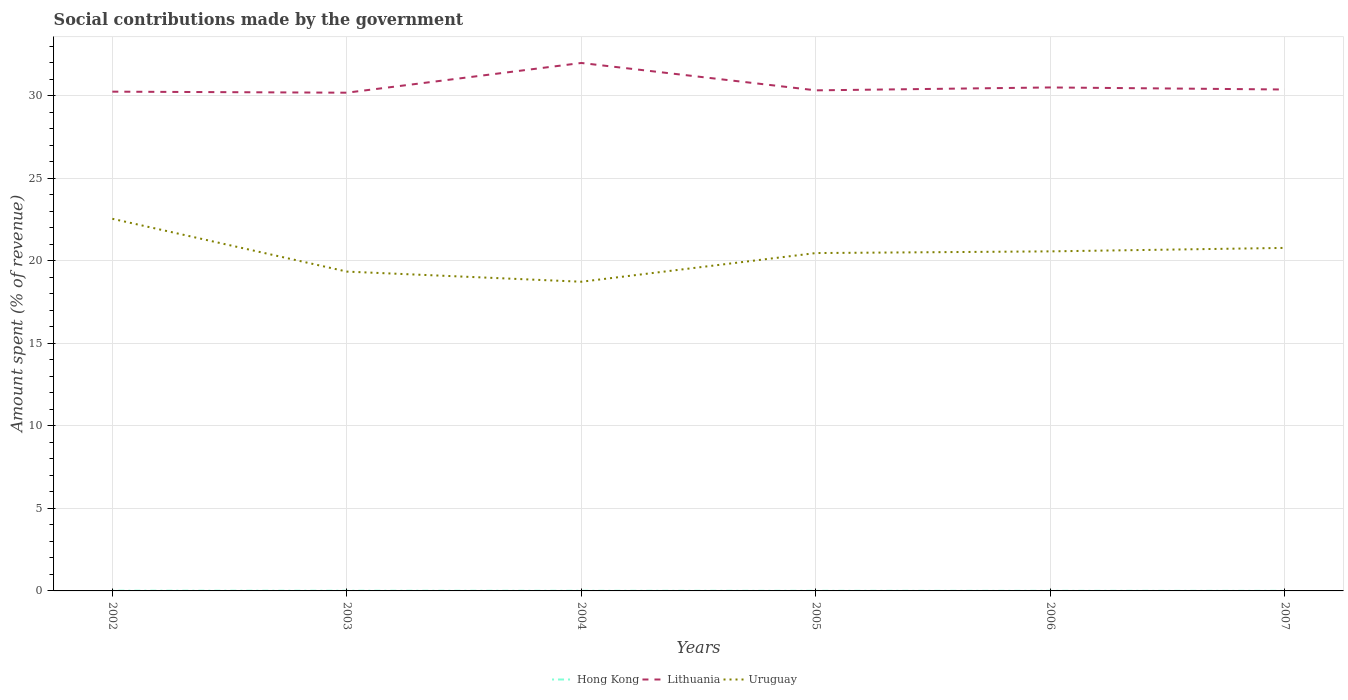Is the number of lines equal to the number of legend labels?
Give a very brief answer. Yes. Across all years, what is the maximum amount spent (in %) on social contributions in Uruguay?
Make the answer very short. 18.74. In which year was the amount spent (in %) on social contributions in Uruguay maximum?
Provide a succinct answer. 2004. What is the total amount spent (in %) on social contributions in Lithuania in the graph?
Your answer should be compact. -0.14. What is the difference between the highest and the second highest amount spent (in %) on social contributions in Hong Kong?
Your answer should be compact. 0.01. How many years are there in the graph?
Provide a succinct answer. 6. What is the difference between two consecutive major ticks on the Y-axis?
Provide a short and direct response. 5. Are the values on the major ticks of Y-axis written in scientific E-notation?
Keep it short and to the point. No. Does the graph contain any zero values?
Ensure brevity in your answer.  No. Does the graph contain grids?
Offer a very short reply. Yes. Where does the legend appear in the graph?
Offer a very short reply. Bottom center. What is the title of the graph?
Your answer should be very brief. Social contributions made by the government. Does "Mongolia" appear as one of the legend labels in the graph?
Your answer should be very brief. No. What is the label or title of the Y-axis?
Your answer should be very brief. Amount spent (% of revenue). What is the Amount spent (% of revenue) of Hong Kong in 2002?
Provide a short and direct response. 0.01. What is the Amount spent (% of revenue) of Lithuania in 2002?
Ensure brevity in your answer.  30.25. What is the Amount spent (% of revenue) of Uruguay in 2002?
Offer a terse response. 22.55. What is the Amount spent (% of revenue) in Hong Kong in 2003?
Ensure brevity in your answer.  0.01. What is the Amount spent (% of revenue) of Lithuania in 2003?
Your answer should be compact. 30.19. What is the Amount spent (% of revenue) of Uruguay in 2003?
Your answer should be compact. 19.35. What is the Amount spent (% of revenue) of Hong Kong in 2004?
Offer a terse response. 0.01. What is the Amount spent (% of revenue) of Lithuania in 2004?
Make the answer very short. 31.99. What is the Amount spent (% of revenue) in Uruguay in 2004?
Your answer should be compact. 18.74. What is the Amount spent (% of revenue) of Hong Kong in 2005?
Offer a terse response. 0.01. What is the Amount spent (% of revenue) of Lithuania in 2005?
Make the answer very short. 30.33. What is the Amount spent (% of revenue) in Uruguay in 2005?
Offer a very short reply. 20.47. What is the Amount spent (% of revenue) in Hong Kong in 2006?
Offer a terse response. 0.01. What is the Amount spent (% of revenue) of Lithuania in 2006?
Offer a terse response. 30.51. What is the Amount spent (% of revenue) of Uruguay in 2006?
Keep it short and to the point. 20.58. What is the Amount spent (% of revenue) in Hong Kong in 2007?
Offer a very short reply. 0. What is the Amount spent (% of revenue) in Lithuania in 2007?
Provide a succinct answer. 30.38. What is the Amount spent (% of revenue) in Uruguay in 2007?
Your answer should be very brief. 20.79. Across all years, what is the maximum Amount spent (% of revenue) of Hong Kong?
Offer a very short reply. 0.01. Across all years, what is the maximum Amount spent (% of revenue) in Lithuania?
Your response must be concise. 31.99. Across all years, what is the maximum Amount spent (% of revenue) in Uruguay?
Make the answer very short. 22.55. Across all years, what is the minimum Amount spent (% of revenue) in Hong Kong?
Offer a terse response. 0. Across all years, what is the minimum Amount spent (% of revenue) in Lithuania?
Make the answer very short. 30.19. Across all years, what is the minimum Amount spent (% of revenue) in Uruguay?
Keep it short and to the point. 18.74. What is the total Amount spent (% of revenue) in Hong Kong in the graph?
Make the answer very short. 0.05. What is the total Amount spent (% of revenue) of Lithuania in the graph?
Your response must be concise. 183.66. What is the total Amount spent (% of revenue) of Uruguay in the graph?
Your response must be concise. 122.47. What is the difference between the Amount spent (% of revenue) in Hong Kong in 2002 and that in 2003?
Give a very brief answer. 0. What is the difference between the Amount spent (% of revenue) in Lithuania in 2002 and that in 2003?
Offer a terse response. 0.06. What is the difference between the Amount spent (% of revenue) of Uruguay in 2002 and that in 2003?
Your answer should be compact. 3.2. What is the difference between the Amount spent (% of revenue) in Hong Kong in 2002 and that in 2004?
Keep it short and to the point. 0.01. What is the difference between the Amount spent (% of revenue) of Lithuania in 2002 and that in 2004?
Your answer should be compact. -1.74. What is the difference between the Amount spent (% of revenue) in Uruguay in 2002 and that in 2004?
Give a very brief answer. 3.81. What is the difference between the Amount spent (% of revenue) of Hong Kong in 2002 and that in 2005?
Your answer should be very brief. 0.01. What is the difference between the Amount spent (% of revenue) in Lithuania in 2002 and that in 2005?
Make the answer very short. -0.08. What is the difference between the Amount spent (% of revenue) in Uruguay in 2002 and that in 2005?
Give a very brief answer. 2.08. What is the difference between the Amount spent (% of revenue) in Hong Kong in 2002 and that in 2006?
Make the answer very short. 0.01. What is the difference between the Amount spent (% of revenue) in Lithuania in 2002 and that in 2006?
Offer a terse response. -0.25. What is the difference between the Amount spent (% of revenue) in Uruguay in 2002 and that in 2006?
Your response must be concise. 1.97. What is the difference between the Amount spent (% of revenue) of Hong Kong in 2002 and that in 2007?
Offer a very short reply. 0.01. What is the difference between the Amount spent (% of revenue) in Lithuania in 2002 and that in 2007?
Offer a terse response. -0.13. What is the difference between the Amount spent (% of revenue) of Uruguay in 2002 and that in 2007?
Ensure brevity in your answer.  1.76. What is the difference between the Amount spent (% of revenue) of Hong Kong in 2003 and that in 2004?
Provide a succinct answer. 0. What is the difference between the Amount spent (% of revenue) of Lithuania in 2003 and that in 2004?
Make the answer very short. -1.8. What is the difference between the Amount spent (% of revenue) of Uruguay in 2003 and that in 2004?
Provide a succinct answer. 0.61. What is the difference between the Amount spent (% of revenue) of Hong Kong in 2003 and that in 2005?
Your answer should be compact. 0. What is the difference between the Amount spent (% of revenue) in Lithuania in 2003 and that in 2005?
Offer a terse response. -0.14. What is the difference between the Amount spent (% of revenue) of Uruguay in 2003 and that in 2005?
Ensure brevity in your answer.  -1.12. What is the difference between the Amount spent (% of revenue) in Hong Kong in 2003 and that in 2006?
Your response must be concise. 0.01. What is the difference between the Amount spent (% of revenue) in Lithuania in 2003 and that in 2006?
Offer a very short reply. -0.32. What is the difference between the Amount spent (% of revenue) in Uruguay in 2003 and that in 2006?
Ensure brevity in your answer.  -1.23. What is the difference between the Amount spent (% of revenue) of Hong Kong in 2003 and that in 2007?
Ensure brevity in your answer.  0.01. What is the difference between the Amount spent (% of revenue) in Lithuania in 2003 and that in 2007?
Provide a short and direct response. -0.19. What is the difference between the Amount spent (% of revenue) of Uruguay in 2003 and that in 2007?
Offer a very short reply. -1.44. What is the difference between the Amount spent (% of revenue) in Hong Kong in 2004 and that in 2005?
Provide a short and direct response. 0. What is the difference between the Amount spent (% of revenue) in Lithuania in 2004 and that in 2005?
Keep it short and to the point. 1.66. What is the difference between the Amount spent (% of revenue) in Uruguay in 2004 and that in 2005?
Provide a short and direct response. -1.74. What is the difference between the Amount spent (% of revenue) of Hong Kong in 2004 and that in 2006?
Give a very brief answer. 0. What is the difference between the Amount spent (% of revenue) of Lithuania in 2004 and that in 2006?
Offer a very short reply. 1.48. What is the difference between the Amount spent (% of revenue) in Uruguay in 2004 and that in 2006?
Offer a terse response. -1.84. What is the difference between the Amount spent (% of revenue) in Hong Kong in 2004 and that in 2007?
Provide a short and direct response. 0. What is the difference between the Amount spent (% of revenue) in Lithuania in 2004 and that in 2007?
Ensure brevity in your answer.  1.61. What is the difference between the Amount spent (% of revenue) of Uruguay in 2004 and that in 2007?
Your answer should be very brief. -2.05. What is the difference between the Amount spent (% of revenue) of Hong Kong in 2005 and that in 2006?
Provide a succinct answer. 0. What is the difference between the Amount spent (% of revenue) of Lithuania in 2005 and that in 2006?
Your answer should be compact. -0.18. What is the difference between the Amount spent (% of revenue) of Uruguay in 2005 and that in 2006?
Keep it short and to the point. -0.1. What is the difference between the Amount spent (% of revenue) in Hong Kong in 2005 and that in 2007?
Make the answer very short. 0. What is the difference between the Amount spent (% of revenue) of Lithuania in 2005 and that in 2007?
Your answer should be compact. -0.05. What is the difference between the Amount spent (% of revenue) of Uruguay in 2005 and that in 2007?
Give a very brief answer. -0.31. What is the difference between the Amount spent (% of revenue) in Hong Kong in 2006 and that in 2007?
Your answer should be compact. 0. What is the difference between the Amount spent (% of revenue) of Lithuania in 2006 and that in 2007?
Make the answer very short. 0.12. What is the difference between the Amount spent (% of revenue) of Uruguay in 2006 and that in 2007?
Provide a short and direct response. -0.21. What is the difference between the Amount spent (% of revenue) in Hong Kong in 2002 and the Amount spent (% of revenue) in Lithuania in 2003?
Your answer should be compact. -30.18. What is the difference between the Amount spent (% of revenue) in Hong Kong in 2002 and the Amount spent (% of revenue) in Uruguay in 2003?
Provide a short and direct response. -19.34. What is the difference between the Amount spent (% of revenue) in Lithuania in 2002 and the Amount spent (% of revenue) in Uruguay in 2003?
Your answer should be very brief. 10.9. What is the difference between the Amount spent (% of revenue) in Hong Kong in 2002 and the Amount spent (% of revenue) in Lithuania in 2004?
Ensure brevity in your answer.  -31.98. What is the difference between the Amount spent (% of revenue) in Hong Kong in 2002 and the Amount spent (% of revenue) in Uruguay in 2004?
Offer a terse response. -18.72. What is the difference between the Amount spent (% of revenue) in Lithuania in 2002 and the Amount spent (% of revenue) in Uruguay in 2004?
Offer a terse response. 11.52. What is the difference between the Amount spent (% of revenue) in Hong Kong in 2002 and the Amount spent (% of revenue) in Lithuania in 2005?
Your answer should be compact. -30.32. What is the difference between the Amount spent (% of revenue) of Hong Kong in 2002 and the Amount spent (% of revenue) of Uruguay in 2005?
Your response must be concise. -20.46. What is the difference between the Amount spent (% of revenue) of Lithuania in 2002 and the Amount spent (% of revenue) of Uruguay in 2005?
Provide a succinct answer. 9.78. What is the difference between the Amount spent (% of revenue) of Hong Kong in 2002 and the Amount spent (% of revenue) of Lithuania in 2006?
Provide a succinct answer. -30.49. What is the difference between the Amount spent (% of revenue) in Hong Kong in 2002 and the Amount spent (% of revenue) in Uruguay in 2006?
Make the answer very short. -20.56. What is the difference between the Amount spent (% of revenue) in Lithuania in 2002 and the Amount spent (% of revenue) in Uruguay in 2006?
Offer a very short reply. 9.68. What is the difference between the Amount spent (% of revenue) in Hong Kong in 2002 and the Amount spent (% of revenue) in Lithuania in 2007?
Ensure brevity in your answer.  -30.37. What is the difference between the Amount spent (% of revenue) of Hong Kong in 2002 and the Amount spent (% of revenue) of Uruguay in 2007?
Your response must be concise. -20.77. What is the difference between the Amount spent (% of revenue) in Lithuania in 2002 and the Amount spent (% of revenue) in Uruguay in 2007?
Offer a terse response. 9.47. What is the difference between the Amount spent (% of revenue) in Hong Kong in 2003 and the Amount spent (% of revenue) in Lithuania in 2004?
Offer a terse response. -31.98. What is the difference between the Amount spent (% of revenue) in Hong Kong in 2003 and the Amount spent (% of revenue) in Uruguay in 2004?
Offer a terse response. -18.72. What is the difference between the Amount spent (% of revenue) in Lithuania in 2003 and the Amount spent (% of revenue) in Uruguay in 2004?
Your answer should be very brief. 11.45. What is the difference between the Amount spent (% of revenue) in Hong Kong in 2003 and the Amount spent (% of revenue) in Lithuania in 2005?
Keep it short and to the point. -30.32. What is the difference between the Amount spent (% of revenue) in Hong Kong in 2003 and the Amount spent (% of revenue) in Uruguay in 2005?
Give a very brief answer. -20.46. What is the difference between the Amount spent (% of revenue) of Lithuania in 2003 and the Amount spent (% of revenue) of Uruguay in 2005?
Make the answer very short. 9.72. What is the difference between the Amount spent (% of revenue) of Hong Kong in 2003 and the Amount spent (% of revenue) of Lithuania in 2006?
Provide a short and direct response. -30.5. What is the difference between the Amount spent (% of revenue) of Hong Kong in 2003 and the Amount spent (% of revenue) of Uruguay in 2006?
Keep it short and to the point. -20.56. What is the difference between the Amount spent (% of revenue) of Lithuania in 2003 and the Amount spent (% of revenue) of Uruguay in 2006?
Make the answer very short. 9.62. What is the difference between the Amount spent (% of revenue) in Hong Kong in 2003 and the Amount spent (% of revenue) in Lithuania in 2007?
Ensure brevity in your answer.  -30.37. What is the difference between the Amount spent (% of revenue) of Hong Kong in 2003 and the Amount spent (% of revenue) of Uruguay in 2007?
Make the answer very short. -20.77. What is the difference between the Amount spent (% of revenue) of Lithuania in 2003 and the Amount spent (% of revenue) of Uruguay in 2007?
Make the answer very short. 9.41. What is the difference between the Amount spent (% of revenue) of Hong Kong in 2004 and the Amount spent (% of revenue) of Lithuania in 2005?
Your response must be concise. -30.32. What is the difference between the Amount spent (% of revenue) of Hong Kong in 2004 and the Amount spent (% of revenue) of Uruguay in 2005?
Give a very brief answer. -20.47. What is the difference between the Amount spent (% of revenue) of Lithuania in 2004 and the Amount spent (% of revenue) of Uruguay in 2005?
Offer a terse response. 11.52. What is the difference between the Amount spent (% of revenue) of Hong Kong in 2004 and the Amount spent (% of revenue) of Lithuania in 2006?
Give a very brief answer. -30.5. What is the difference between the Amount spent (% of revenue) of Hong Kong in 2004 and the Amount spent (% of revenue) of Uruguay in 2006?
Offer a very short reply. -20.57. What is the difference between the Amount spent (% of revenue) in Lithuania in 2004 and the Amount spent (% of revenue) in Uruguay in 2006?
Provide a succinct answer. 11.42. What is the difference between the Amount spent (% of revenue) of Hong Kong in 2004 and the Amount spent (% of revenue) of Lithuania in 2007?
Give a very brief answer. -30.38. What is the difference between the Amount spent (% of revenue) of Hong Kong in 2004 and the Amount spent (% of revenue) of Uruguay in 2007?
Offer a very short reply. -20.78. What is the difference between the Amount spent (% of revenue) of Lithuania in 2004 and the Amount spent (% of revenue) of Uruguay in 2007?
Give a very brief answer. 11.21. What is the difference between the Amount spent (% of revenue) in Hong Kong in 2005 and the Amount spent (% of revenue) in Lithuania in 2006?
Provide a short and direct response. -30.5. What is the difference between the Amount spent (% of revenue) in Hong Kong in 2005 and the Amount spent (% of revenue) in Uruguay in 2006?
Give a very brief answer. -20.57. What is the difference between the Amount spent (% of revenue) of Lithuania in 2005 and the Amount spent (% of revenue) of Uruguay in 2006?
Provide a succinct answer. 9.76. What is the difference between the Amount spent (% of revenue) of Hong Kong in 2005 and the Amount spent (% of revenue) of Lithuania in 2007?
Offer a very short reply. -30.38. What is the difference between the Amount spent (% of revenue) of Hong Kong in 2005 and the Amount spent (% of revenue) of Uruguay in 2007?
Provide a short and direct response. -20.78. What is the difference between the Amount spent (% of revenue) of Lithuania in 2005 and the Amount spent (% of revenue) of Uruguay in 2007?
Keep it short and to the point. 9.55. What is the difference between the Amount spent (% of revenue) of Hong Kong in 2006 and the Amount spent (% of revenue) of Lithuania in 2007?
Your answer should be compact. -30.38. What is the difference between the Amount spent (% of revenue) of Hong Kong in 2006 and the Amount spent (% of revenue) of Uruguay in 2007?
Make the answer very short. -20.78. What is the difference between the Amount spent (% of revenue) in Lithuania in 2006 and the Amount spent (% of revenue) in Uruguay in 2007?
Ensure brevity in your answer.  9.72. What is the average Amount spent (% of revenue) of Hong Kong per year?
Your answer should be very brief. 0.01. What is the average Amount spent (% of revenue) in Lithuania per year?
Your response must be concise. 30.61. What is the average Amount spent (% of revenue) in Uruguay per year?
Keep it short and to the point. 20.41. In the year 2002, what is the difference between the Amount spent (% of revenue) in Hong Kong and Amount spent (% of revenue) in Lithuania?
Provide a succinct answer. -30.24. In the year 2002, what is the difference between the Amount spent (% of revenue) of Hong Kong and Amount spent (% of revenue) of Uruguay?
Ensure brevity in your answer.  -22.54. In the year 2002, what is the difference between the Amount spent (% of revenue) in Lithuania and Amount spent (% of revenue) in Uruguay?
Your response must be concise. 7.7. In the year 2003, what is the difference between the Amount spent (% of revenue) of Hong Kong and Amount spent (% of revenue) of Lithuania?
Provide a succinct answer. -30.18. In the year 2003, what is the difference between the Amount spent (% of revenue) in Hong Kong and Amount spent (% of revenue) in Uruguay?
Offer a terse response. -19.34. In the year 2003, what is the difference between the Amount spent (% of revenue) in Lithuania and Amount spent (% of revenue) in Uruguay?
Ensure brevity in your answer.  10.84. In the year 2004, what is the difference between the Amount spent (% of revenue) in Hong Kong and Amount spent (% of revenue) in Lithuania?
Keep it short and to the point. -31.98. In the year 2004, what is the difference between the Amount spent (% of revenue) in Hong Kong and Amount spent (% of revenue) in Uruguay?
Offer a terse response. -18.73. In the year 2004, what is the difference between the Amount spent (% of revenue) in Lithuania and Amount spent (% of revenue) in Uruguay?
Ensure brevity in your answer.  13.26. In the year 2005, what is the difference between the Amount spent (% of revenue) in Hong Kong and Amount spent (% of revenue) in Lithuania?
Your response must be concise. -30.33. In the year 2005, what is the difference between the Amount spent (% of revenue) in Hong Kong and Amount spent (% of revenue) in Uruguay?
Your answer should be compact. -20.47. In the year 2005, what is the difference between the Amount spent (% of revenue) in Lithuania and Amount spent (% of revenue) in Uruguay?
Provide a succinct answer. 9.86. In the year 2006, what is the difference between the Amount spent (% of revenue) in Hong Kong and Amount spent (% of revenue) in Lithuania?
Your response must be concise. -30.5. In the year 2006, what is the difference between the Amount spent (% of revenue) in Hong Kong and Amount spent (% of revenue) in Uruguay?
Keep it short and to the point. -20.57. In the year 2006, what is the difference between the Amount spent (% of revenue) of Lithuania and Amount spent (% of revenue) of Uruguay?
Provide a short and direct response. 9.93. In the year 2007, what is the difference between the Amount spent (% of revenue) of Hong Kong and Amount spent (% of revenue) of Lithuania?
Make the answer very short. -30.38. In the year 2007, what is the difference between the Amount spent (% of revenue) of Hong Kong and Amount spent (% of revenue) of Uruguay?
Offer a terse response. -20.78. In the year 2007, what is the difference between the Amount spent (% of revenue) of Lithuania and Amount spent (% of revenue) of Uruguay?
Make the answer very short. 9.6. What is the ratio of the Amount spent (% of revenue) of Hong Kong in 2002 to that in 2003?
Your response must be concise. 1.21. What is the ratio of the Amount spent (% of revenue) of Uruguay in 2002 to that in 2003?
Ensure brevity in your answer.  1.17. What is the ratio of the Amount spent (% of revenue) of Hong Kong in 2002 to that in 2004?
Your answer should be very brief. 1.68. What is the ratio of the Amount spent (% of revenue) of Lithuania in 2002 to that in 2004?
Offer a very short reply. 0.95. What is the ratio of the Amount spent (% of revenue) in Uruguay in 2002 to that in 2004?
Ensure brevity in your answer.  1.2. What is the ratio of the Amount spent (% of revenue) of Hong Kong in 2002 to that in 2005?
Make the answer very short. 2.1. What is the ratio of the Amount spent (% of revenue) of Lithuania in 2002 to that in 2005?
Your answer should be very brief. 1. What is the ratio of the Amount spent (% of revenue) of Uruguay in 2002 to that in 2005?
Offer a very short reply. 1.1. What is the ratio of the Amount spent (% of revenue) of Hong Kong in 2002 to that in 2006?
Offer a very short reply. 2.45. What is the ratio of the Amount spent (% of revenue) of Uruguay in 2002 to that in 2006?
Provide a succinct answer. 1.1. What is the ratio of the Amount spent (% of revenue) in Hong Kong in 2002 to that in 2007?
Offer a very short reply. 2.96. What is the ratio of the Amount spent (% of revenue) of Uruguay in 2002 to that in 2007?
Your response must be concise. 1.08. What is the ratio of the Amount spent (% of revenue) in Hong Kong in 2003 to that in 2004?
Keep it short and to the point. 1.39. What is the ratio of the Amount spent (% of revenue) of Lithuania in 2003 to that in 2004?
Ensure brevity in your answer.  0.94. What is the ratio of the Amount spent (% of revenue) of Uruguay in 2003 to that in 2004?
Offer a terse response. 1.03. What is the ratio of the Amount spent (% of revenue) in Hong Kong in 2003 to that in 2005?
Give a very brief answer. 1.73. What is the ratio of the Amount spent (% of revenue) in Lithuania in 2003 to that in 2005?
Your answer should be compact. 1. What is the ratio of the Amount spent (% of revenue) in Uruguay in 2003 to that in 2005?
Give a very brief answer. 0.95. What is the ratio of the Amount spent (% of revenue) of Hong Kong in 2003 to that in 2006?
Keep it short and to the point. 2.02. What is the ratio of the Amount spent (% of revenue) of Lithuania in 2003 to that in 2006?
Your answer should be compact. 0.99. What is the ratio of the Amount spent (% of revenue) of Uruguay in 2003 to that in 2006?
Offer a very short reply. 0.94. What is the ratio of the Amount spent (% of revenue) in Hong Kong in 2003 to that in 2007?
Give a very brief answer. 2.44. What is the ratio of the Amount spent (% of revenue) in Lithuania in 2003 to that in 2007?
Your answer should be compact. 0.99. What is the ratio of the Amount spent (% of revenue) of Uruguay in 2003 to that in 2007?
Make the answer very short. 0.93. What is the ratio of the Amount spent (% of revenue) of Hong Kong in 2004 to that in 2005?
Ensure brevity in your answer.  1.25. What is the ratio of the Amount spent (% of revenue) in Lithuania in 2004 to that in 2005?
Your answer should be compact. 1.05. What is the ratio of the Amount spent (% of revenue) in Uruguay in 2004 to that in 2005?
Your answer should be compact. 0.92. What is the ratio of the Amount spent (% of revenue) of Hong Kong in 2004 to that in 2006?
Provide a short and direct response. 1.46. What is the ratio of the Amount spent (% of revenue) of Lithuania in 2004 to that in 2006?
Provide a short and direct response. 1.05. What is the ratio of the Amount spent (% of revenue) in Uruguay in 2004 to that in 2006?
Make the answer very short. 0.91. What is the ratio of the Amount spent (% of revenue) in Hong Kong in 2004 to that in 2007?
Offer a terse response. 1.76. What is the ratio of the Amount spent (% of revenue) in Lithuania in 2004 to that in 2007?
Your answer should be compact. 1.05. What is the ratio of the Amount spent (% of revenue) of Uruguay in 2004 to that in 2007?
Make the answer very short. 0.9. What is the ratio of the Amount spent (% of revenue) of Hong Kong in 2005 to that in 2006?
Your answer should be compact. 1.17. What is the ratio of the Amount spent (% of revenue) of Lithuania in 2005 to that in 2006?
Keep it short and to the point. 0.99. What is the ratio of the Amount spent (% of revenue) of Hong Kong in 2005 to that in 2007?
Give a very brief answer. 1.41. What is the ratio of the Amount spent (% of revenue) in Lithuania in 2005 to that in 2007?
Offer a very short reply. 1. What is the ratio of the Amount spent (% of revenue) of Uruguay in 2005 to that in 2007?
Provide a succinct answer. 0.98. What is the ratio of the Amount spent (% of revenue) in Hong Kong in 2006 to that in 2007?
Your answer should be compact. 1.21. What is the ratio of the Amount spent (% of revenue) in Uruguay in 2006 to that in 2007?
Ensure brevity in your answer.  0.99. What is the difference between the highest and the second highest Amount spent (% of revenue) of Hong Kong?
Keep it short and to the point. 0. What is the difference between the highest and the second highest Amount spent (% of revenue) in Lithuania?
Ensure brevity in your answer.  1.48. What is the difference between the highest and the second highest Amount spent (% of revenue) in Uruguay?
Make the answer very short. 1.76. What is the difference between the highest and the lowest Amount spent (% of revenue) of Hong Kong?
Your answer should be very brief. 0.01. What is the difference between the highest and the lowest Amount spent (% of revenue) in Lithuania?
Offer a terse response. 1.8. What is the difference between the highest and the lowest Amount spent (% of revenue) of Uruguay?
Your answer should be very brief. 3.81. 